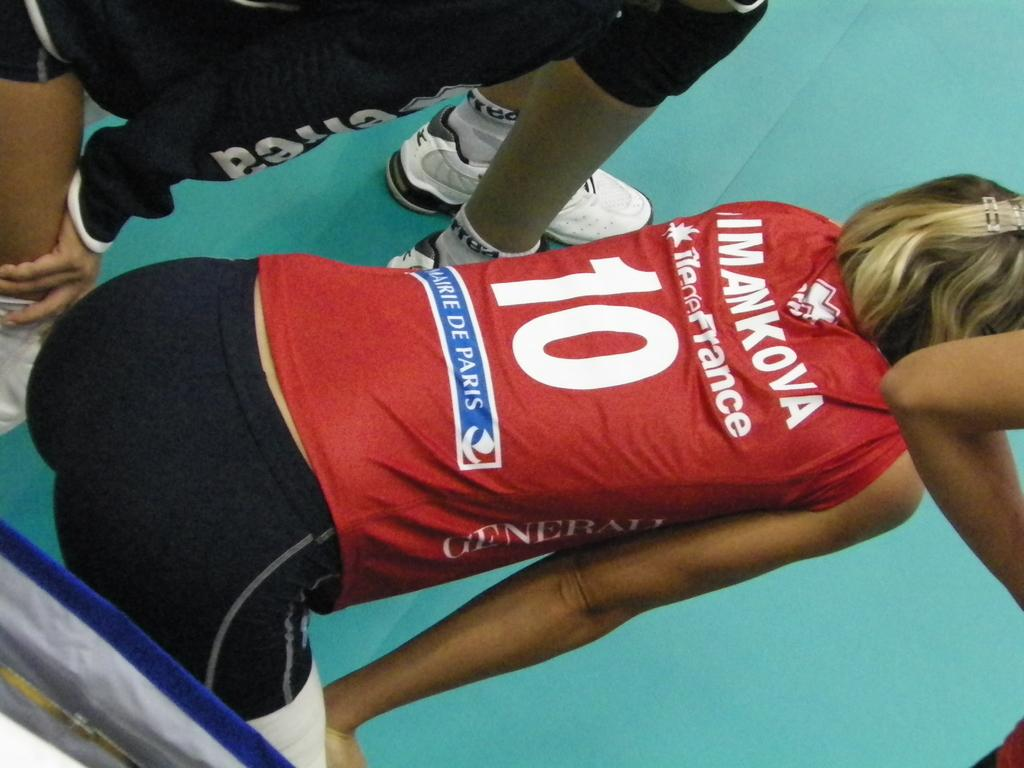<image>
Share a concise interpretation of the image provided. Mankova wears a red jersey with the number 10. 